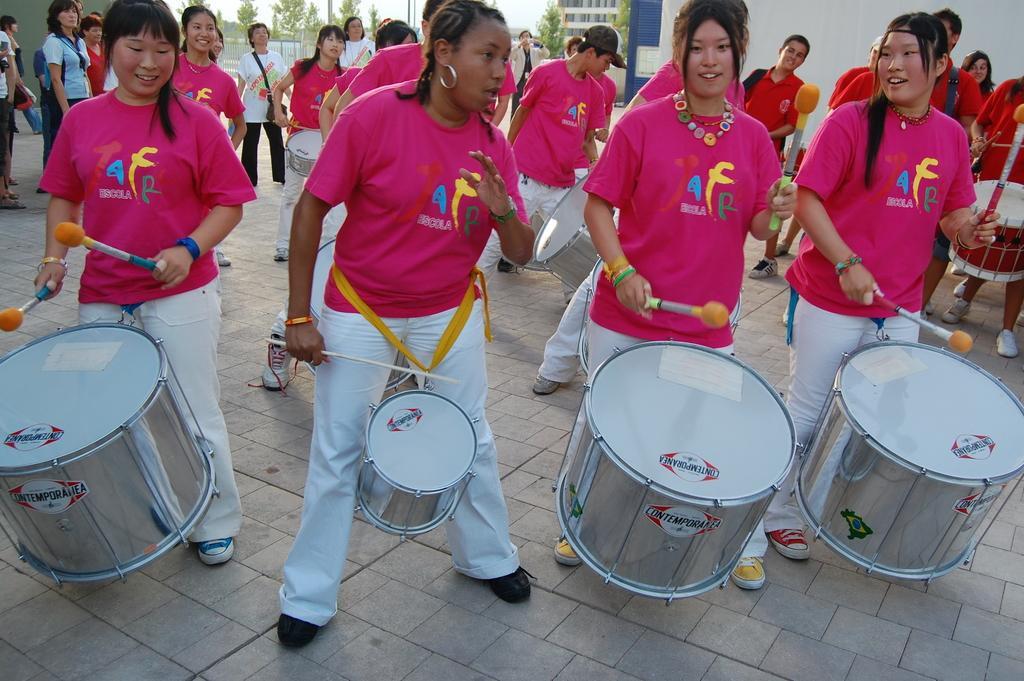What is happening with the group of people in the image? The people are standing and beating drums. Can you describe the people in the background of the image? There is another group of people in the background of the image. What can be seen in the background of the image besides the people? There is a tree, a building, and the sky visible in the background of the image. How many steps are required to reach the top of the boot in the image? There is no boot present in the image. 